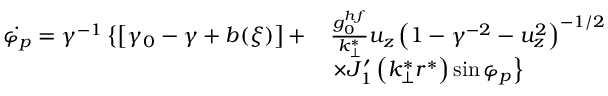Convert formula to latex. <formula><loc_0><loc_0><loc_500><loc_500>\begin{array} { r l } { \dot { \varphi _ { p } } = \gamma ^ { - 1 } \left \{ \left [ \gamma _ { 0 } - \gamma + b ( \xi ) \right ] + } & { \frac { g _ { 0 } ^ { h f } } { k _ { \perp } ^ { * } } u _ { z } \left ( 1 - \gamma ^ { - 2 } - u _ { z } ^ { 2 } \right ) ^ { - 1 / 2 } } \\ & { \times J _ { 1 } ^ { \prime } \left ( k _ { \perp } ^ { * } r ^ { * } \right ) \sin \varphi _ { p } \right \} } \end{array}</formula> 